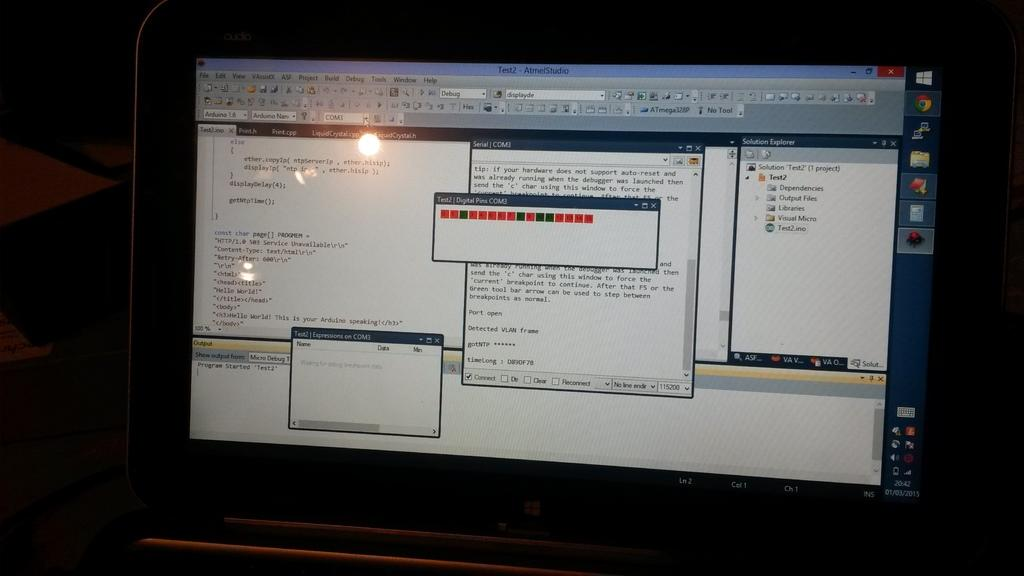Provide a one-sentence caption for the provided image. a computer monitor open to a screen entitled Test2 Atmel Studio. 